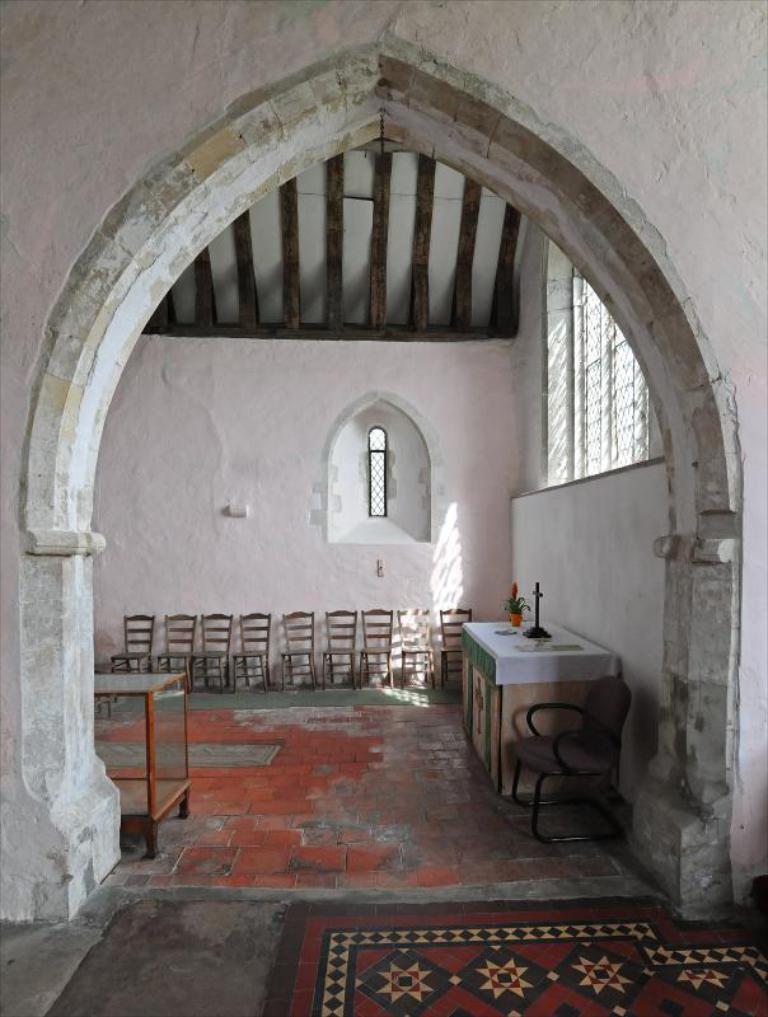How would you summarize this image in a sentence or two? In the center of the image we can see a entrance. On the right side of the image there is a table, flower vase, chair, window and wall. In the background there are chairs, wall and window. 